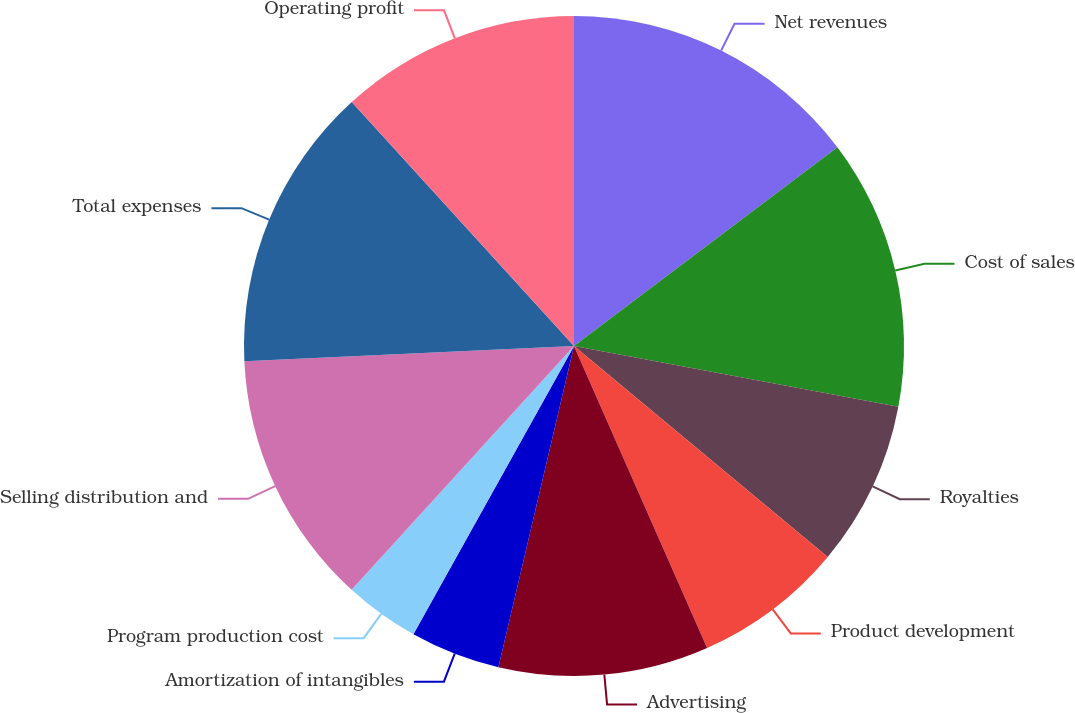<chart> <loc_0><loc_0><loc_500><loc_500><pie_chart><fcel>Net revenues<fcel>Cost of sales<fcel>Royalties<fcel>Product development<fcel>Advertising<fcel>Amortization of intangibles<fcel>Program production cost<fcel>Selling distribution and<fcel>Total expenses<fcel>Operating profit<nl><fcel>14.71%<fcel>13.24%<fcel>8.09%<fcel>7.35%<fcel>10.29%<fcel>4.41%<fcel>3.68%<fcel>12.5%<fcel>13.97%<fcel>11.76%<nl></chart> 